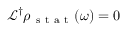Convert formula to latex. <formula><loc_0><loc_0><loc_500><loc_500>\mathcal { L } ^ { \dagger } \rho _ { s t a t } ( \omega ) = 0</formula> 